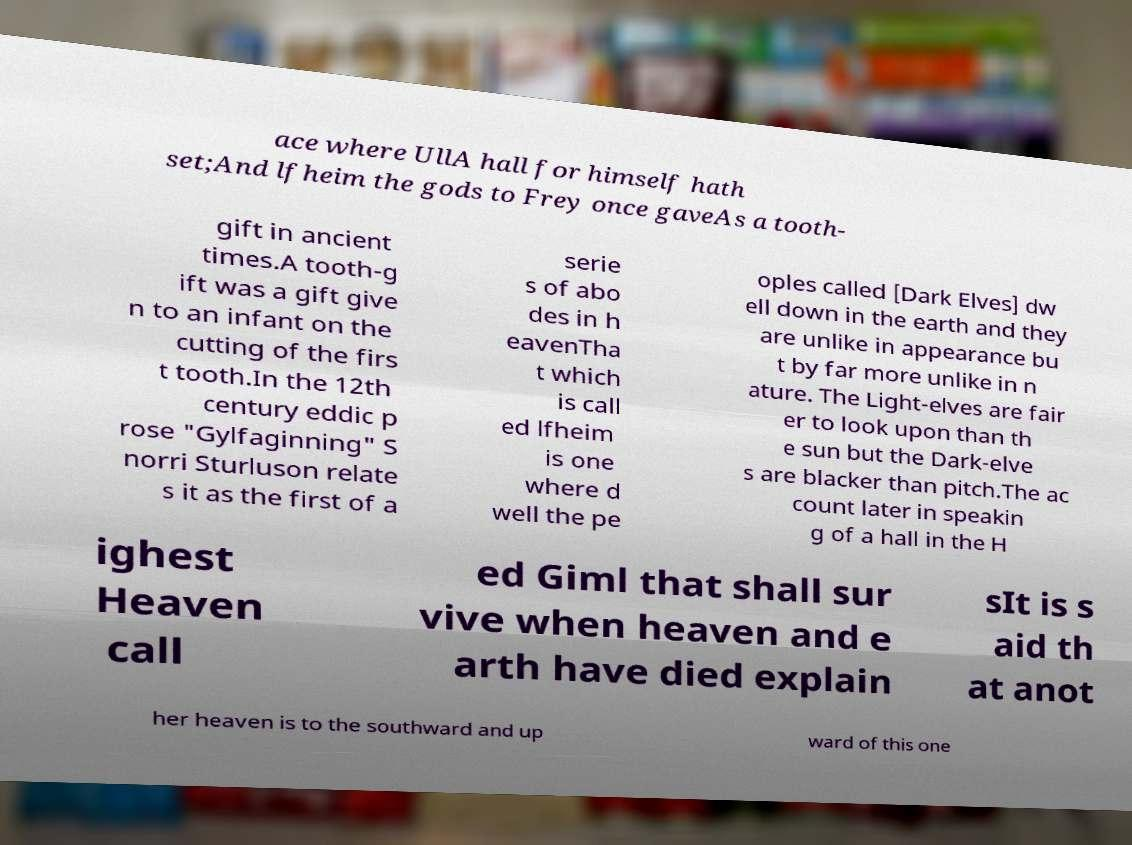Can you accurately transcribe the text from the provided image for me? ace where UllA hall for himself hath set;And lfheim the gods to Frey once gaveAs a tooth- gift in ancient times.A tooth-g ift was a gift give n to an infant on the cutting of the firs t tooth.In the 12th century eddic p rose "Gylfaginning" S norri Sturluson relate s it as the first of a serie s of abo des in h eavenTha t which is call ed lfheim is one where d well the pe oples called [Dark Elves] dw ell down in the earth and they are unlike in appearance bu t by far more unlike in n ature. The Light-elves are fair er to look upon than th e sun but the Dark-elve s are blacker than pitch.The ac count later in speakin g of a hall in the H ighest Heaven call ed Giml that shall sur vive when heaven and e arth have died explain sIt is s aid th at anot her heaven is to the southward and up ward of this one 